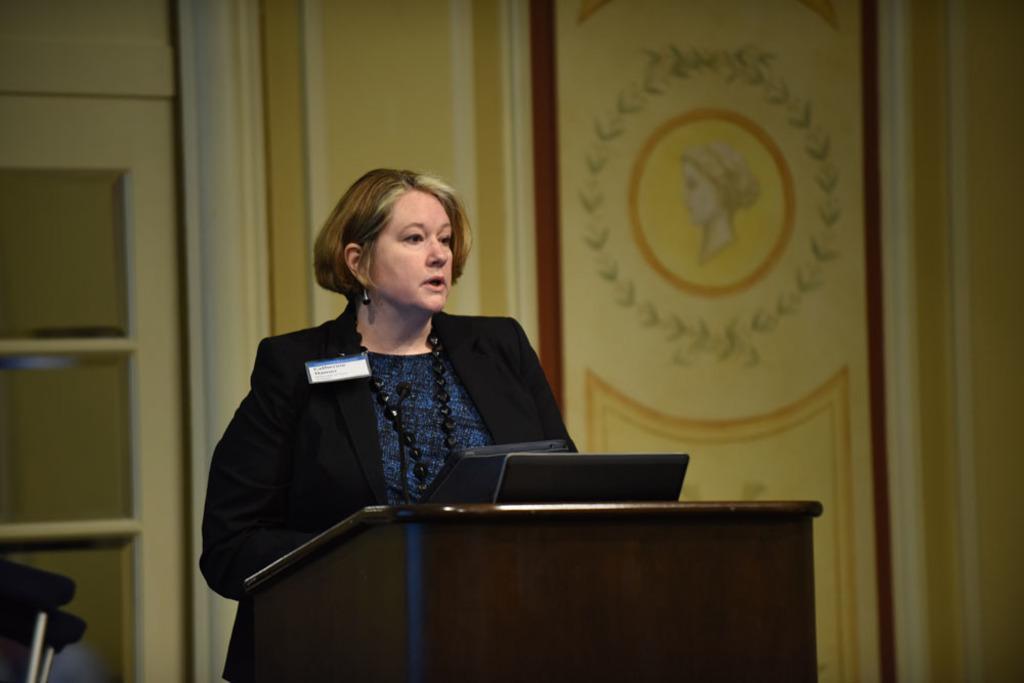Can you describe this image briefly? In this picture I can see a woman standing at a podium and I can see a microphone and a laptop on the podium. I can see a door and picture of a woman on the wall. 